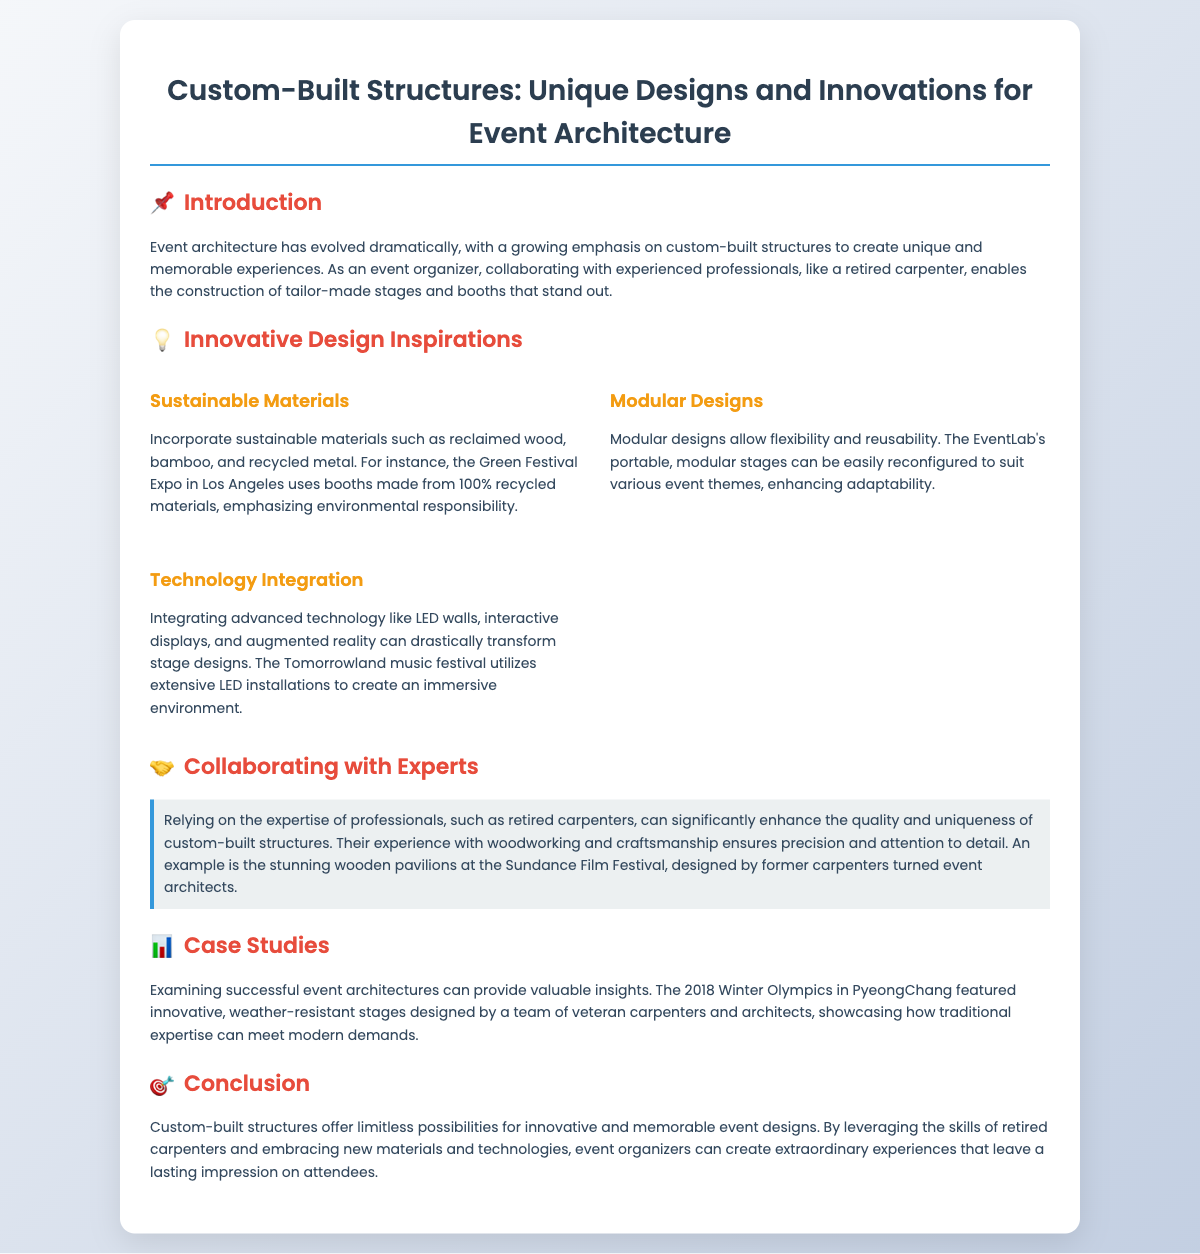What is the title of the presentation? The title of the presentation is stated clearly at the top of the slide.
Answer: Custom-Built Structures: Unique Designs and Innovations for Event Architecture What material emphasizes environmental responsibility? The document mentions sustainable materials that highlight environmental responsibility.
Answer: Recycled materials Which festival uses booths made from 100% recycled materials? The specific event related to the use of recycled materials is given in the document.
Answer: Green Festival Expo What feature allows flexibility in event designs? The document describes an element that contributes to adaptability in structures.
Answer: Modular designs Which technology is integrated to transform stage designs? The document refers to a specific kind of technology that enhances stage designs.
Answer: LED walls What notable example showcases the work of retired carpenters? The document provides a specific example related to the contributions of retired carpenters in event architecture.
Answer: Sundance Film Festival How many case studies are mentioned? The document provides insight into event architectures but only mentions one specific case study.
Answer: One What is the primary benefit of collaborating with retired carpenters? The document highlights a specific advantage of working with skilled professionals like retired carpenters.
Answer: Enhanced quality What event featured innovative, weather-resistant stages? The document includes a notable event where stage designs were showcased.
Answer: 2018 Winter Olympics 